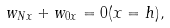Convert formula to latex. <formula><loc_0><loc_0><loc_500><loc_500>w _ { N x } + w _ { 0 x } = 0 ( x = h ) ,</formula> 